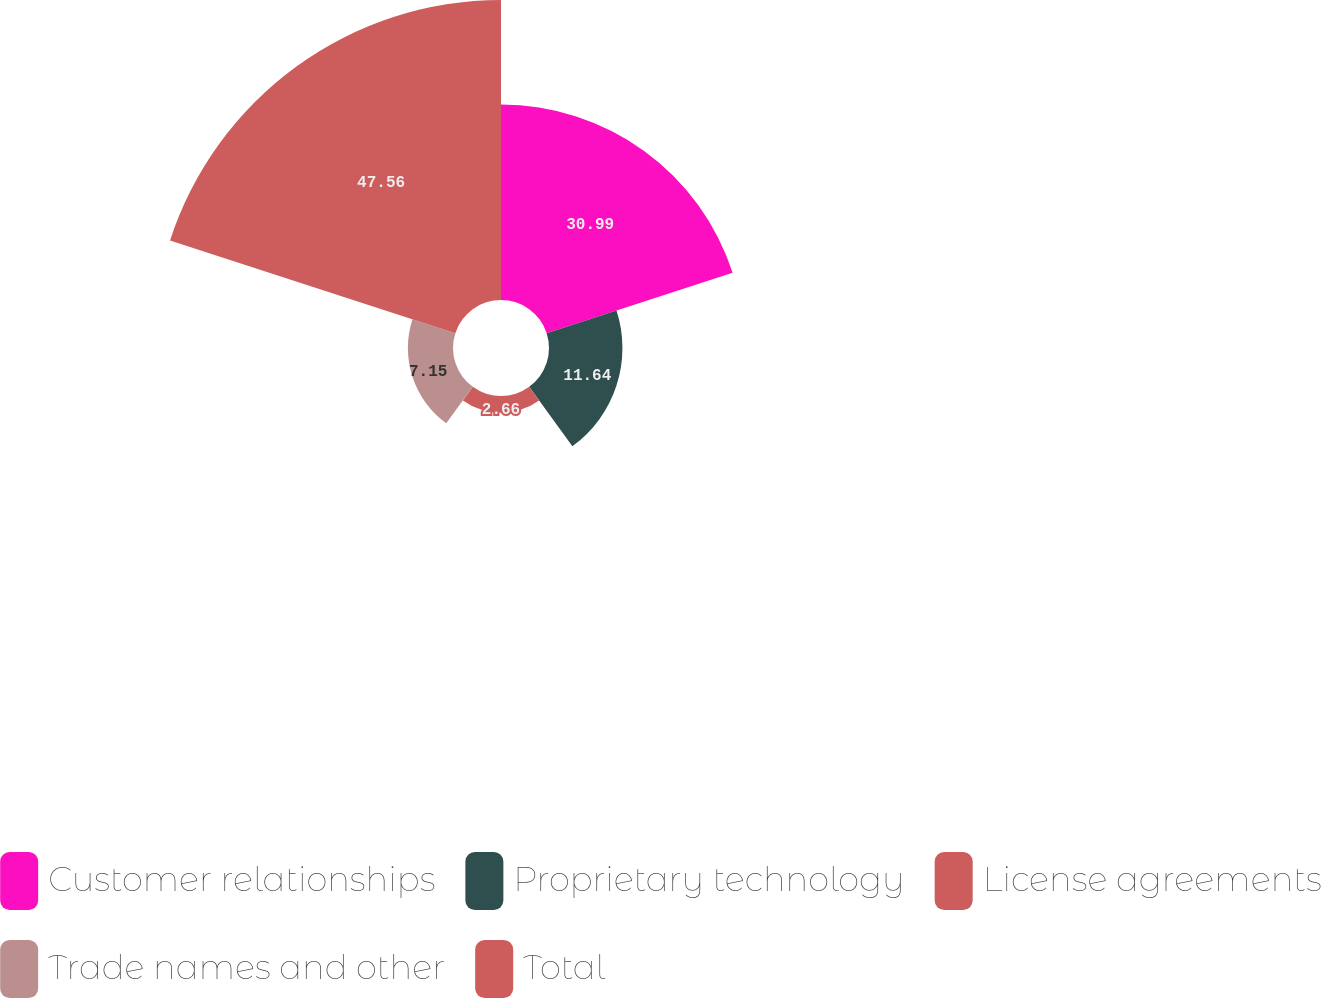Convert chart to OTSL. <chart><loc_0><loc_0><loc_500><loc_500><pie_chart><fcel>Customer relationships<fcel>Proprietary technology<fcel>License agreements<fcel>Trade names and other<fcel>Total<nl><fcel>30.99%<fcel>11.64%<fcel>2.66%<fcel>7.15%<fcel>47.55%<nl></chart> 